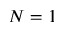Convert formula to latex. <formula><loc_0><loc_0><loc_500><loc_500>N = 1</formula> 